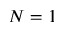Convert formula to latex. <formula><loc_0><loc_0><loc_500><loc_500>N = 1</formula> 